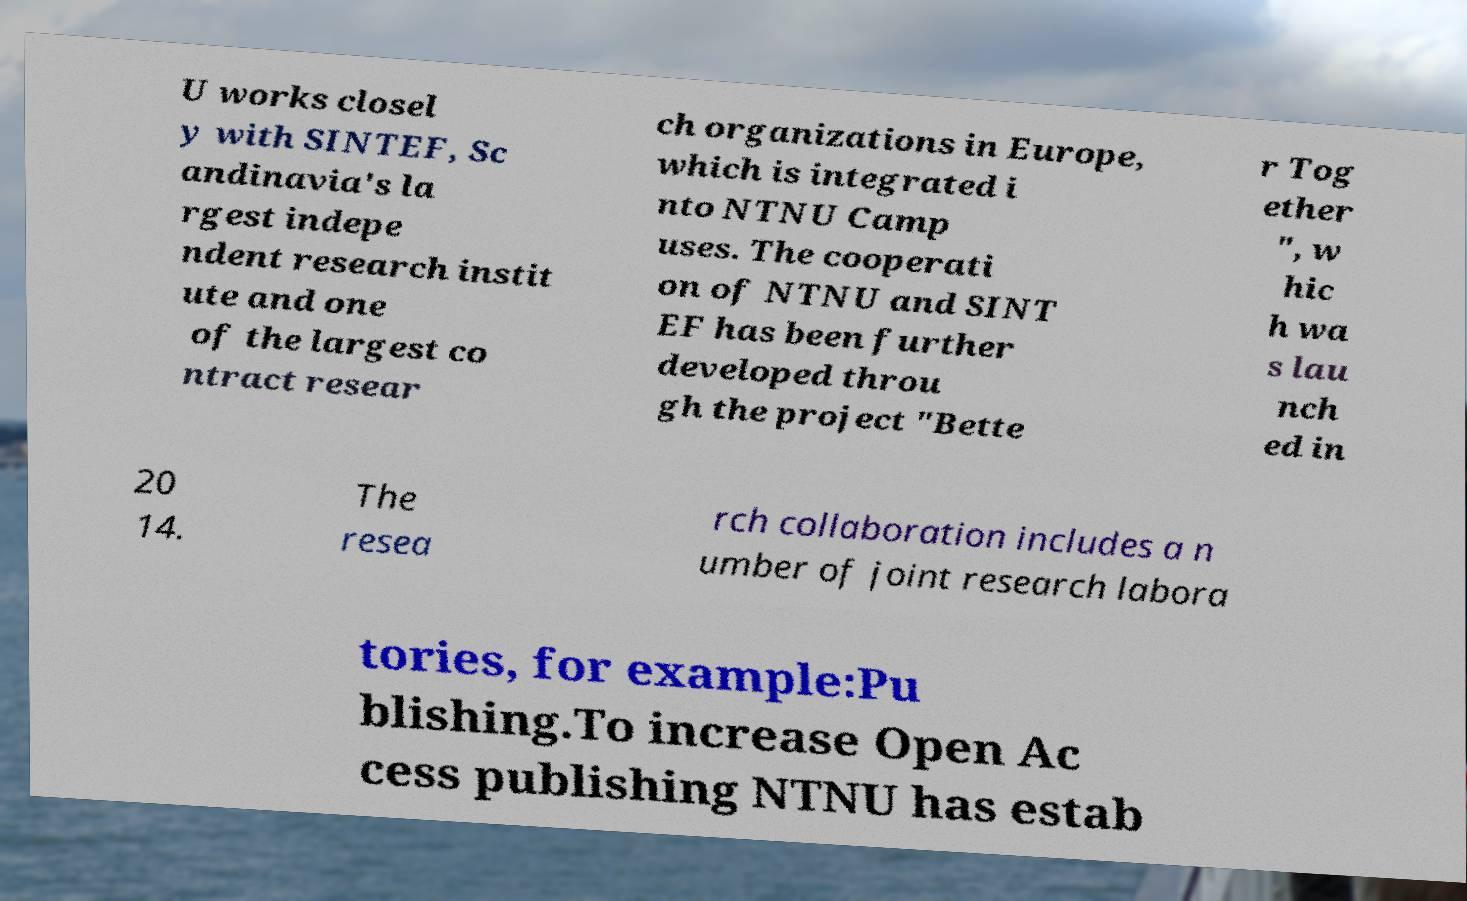Could you extract and type out the text from this image? U works closel y with SINTEF, Sc andinavia's la rgest indepe ndent research instit ute and one of the largest co ntract resear ch organizations in Europe, which is integrated i nto NTNU Camp uses. The cooperati on of NTNU and SINT EF has been further developed throu gh the project "Bette r Tog ether ", w hic h wa s lau nch ed in 20 14. The resea rch collaboration includes a n umber of joint research labora tories, for example:Pu blishing.To increase Open Ac cess publishing NTNU has estab 